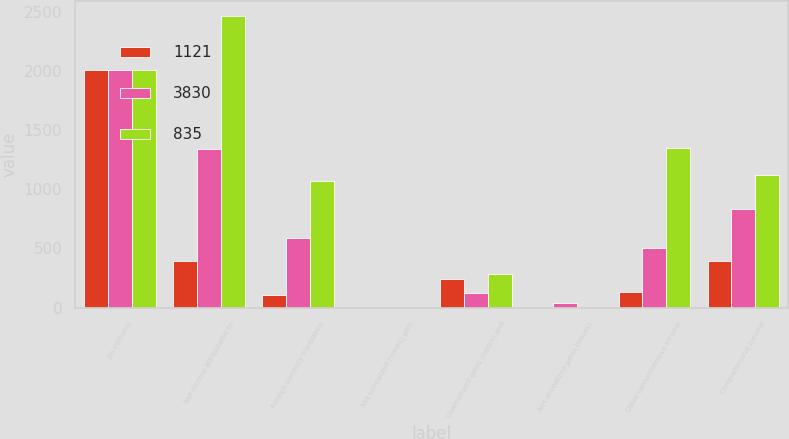Convert chart to OTSL. <chart><loc_0><loc_0><loc_500><loc_500><stacked_bar_chart><ecel><fcel>(in millions)<fcel>Net income attributable to<fcel>Foreign currency translation<fcel>Net unrealized (losses) gain<fcel>Unamortized gains (losses) and<fcel>Net unrealized gains (losses)<fcel>Other comprehensive income<fcel>Comprehensive income<nl><fcel>1121<fcel>2016<fcel>392.5<fcel>104<fcel>3<fcel>241<fcel>1<fcel>135<fcel>392.5<nl><fcel>3830<fcel>2015<fcel>1339<fcel>590<fcel>1<fcel>121<fcel>36<fcel>504<fcel>835<nl><fcel>835<fcel>2014<fcel>2472<fcel>1073<fcel>1<fcel>281<fcel>4<fcel>1351<fcel>1121<nl></chart> 